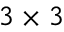Convert formula to latex. <formula><loc_0><loc_0><loc_500><loc_500>3 \times 3</formula> 